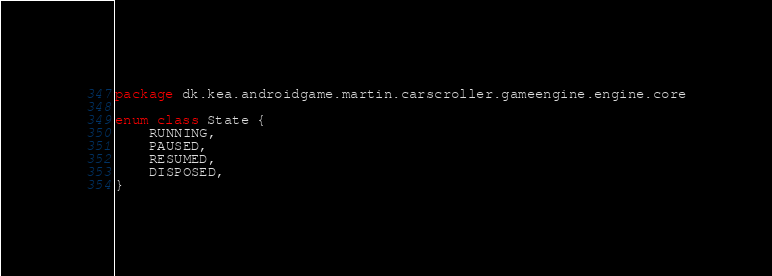<code> <loc_0><loc_0><loc_500><loc_500><_Kotlin_>package dk.kea.androidgame.martin.carscroller.gameengine.engine.core

enum class State {
    RUNNING,
    PAUSED,
    RESUMED,
    DISPOSED,
}
</code> 